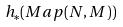<formula> <loc_0><loc_0><loc_500><loc_500>h _ { * } ( M a p ( N , M ) )</formula> 